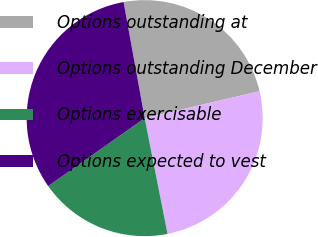<chart> <loc_0><loc_0><loc_500><loc_500><pie_chart><fcel>Options outstanding at<fcel>Options outstanding December<fcel>Options exercisable<fcel>Options expected to vest<nl><fcel>24.2%<fcel>25.56%<fcel>18.34%<fcel>31.9%<nl></chart> 